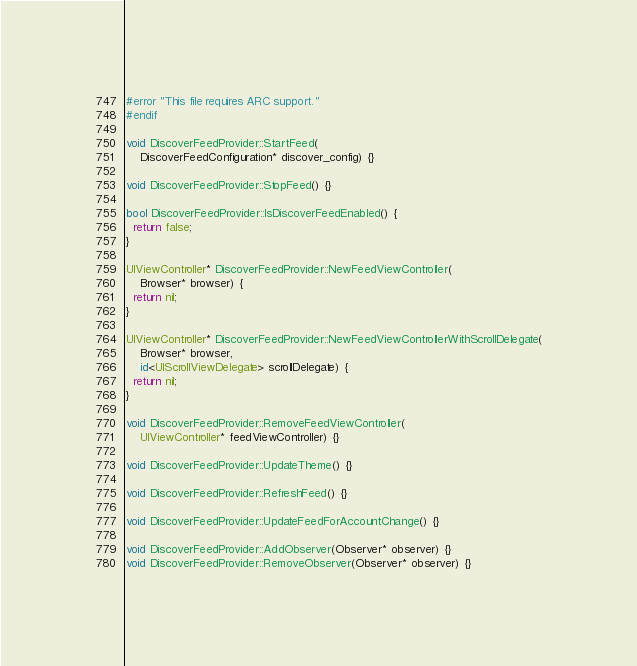Convert code to text. <code><loc_0><loc_0><loc_500><loc_500><_ObjectiveC_>#error "This file requires ARC support."
#endif

void DiscoverFeedProvider::StartFeed(
    DiscoverFeedConfiguration* discover_config) {}

void DiscoverFeedProvider::StopFeed() {}

bool DiscoverFeedProvider::IsDiscoverFeedEnabled() {
  return false;
}

UIViewController* DiscoverFeedProvider::NewFeedViewController(
    Browser* browser) {
  return nil;
}

UIViewController* DiscoverFeedProvider::NewFeedViewControllerWithScrollDelegate(
    Browser* browser,
    id<UIScrollViewDelegate> scrollDelegate) {
  return nil;
}

void DiscoverFeedProvider::RemoveFeedViewController(
    UIViewController* feedViewController) {}

void DiscoverFeedProvider::UpdateTheme() {}

void DiscoverFeedProvider::RefreshFeed() {}

void DiscoverFeedProvider::UpdateFeedForAccountChange() {}

void DiscoverFeedProvider::AddObserver(Observer* observer) {}
void DiscoverFeedProvider::RemoveObserver(Observer* observer) {}</code> 